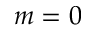Convert formula to latex. <formula><loc_0><loc_0><loc_500><loc_500>m = 0</formula> 